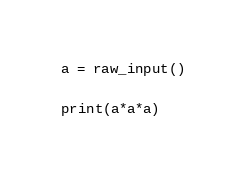Convert code to text. <code><loc_0><loc_0><loc_500><loc_500><_Python_>a = raw_input()

print(a*a*a)</code> 